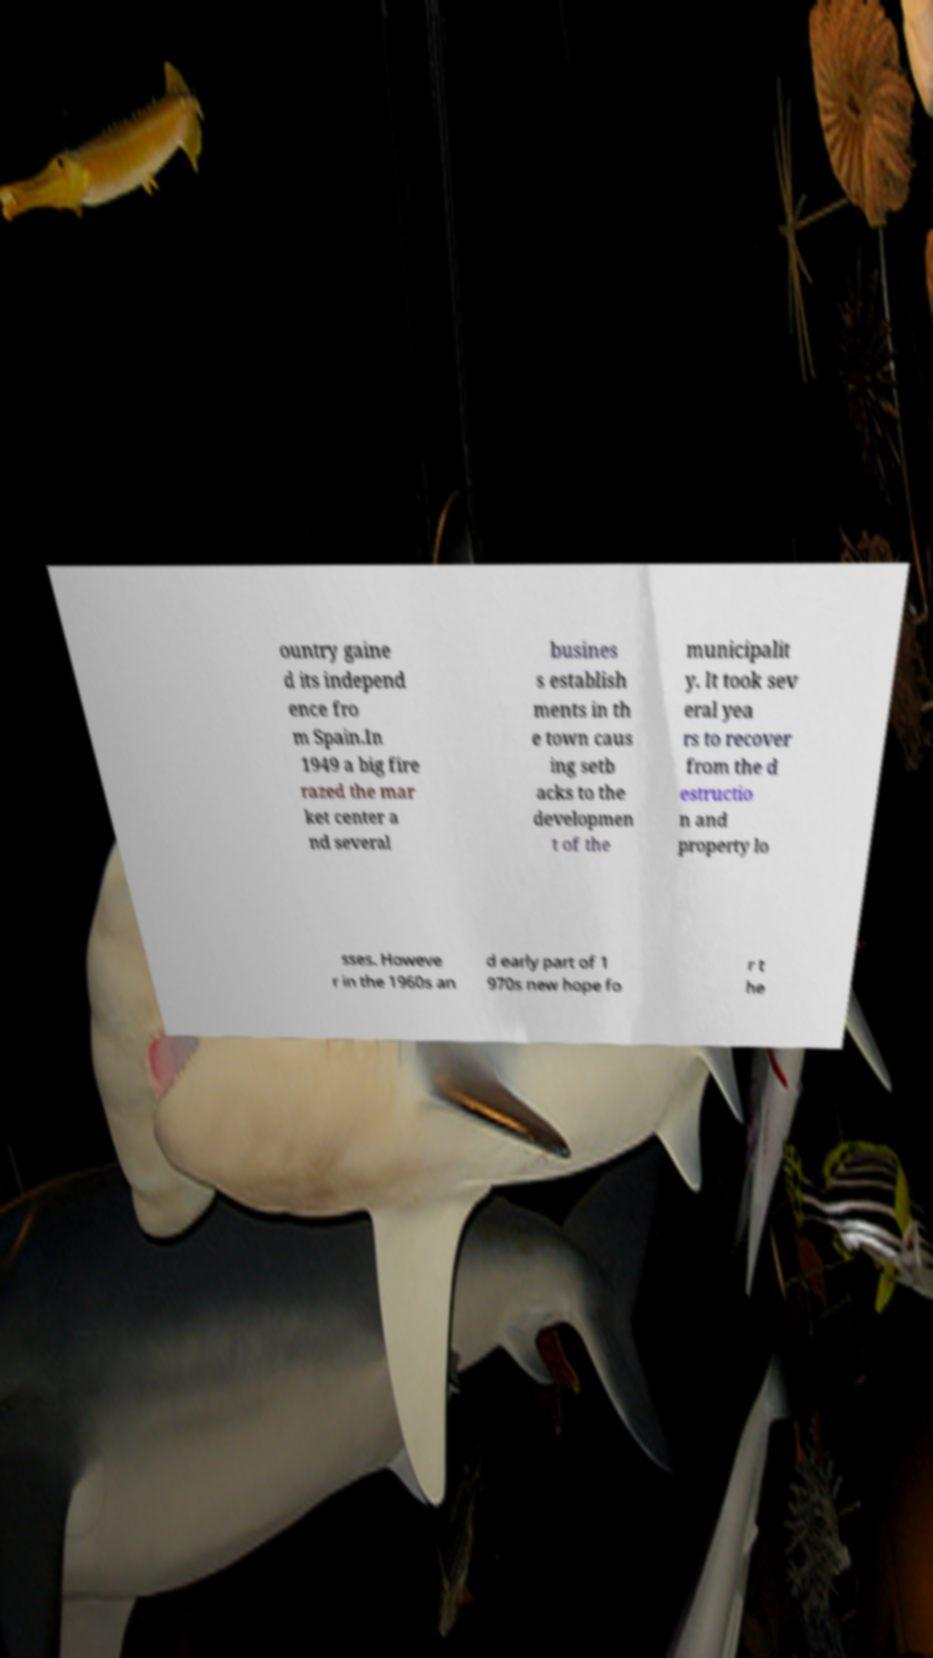Can you accurately transcribe the text from the provided image for me? ountry gaine d its independ ence fro m Spain.In 1949 a big fire razed the mar ket center a nd several busines s establish ments in th e town caus ing setb acks to the developmen t of the municipalit y. It took sev eral yea rs to recover from the d estructio n and property lo sses. Howeve r in the 1960s an d early part of 1 970s new hope fo r t he 